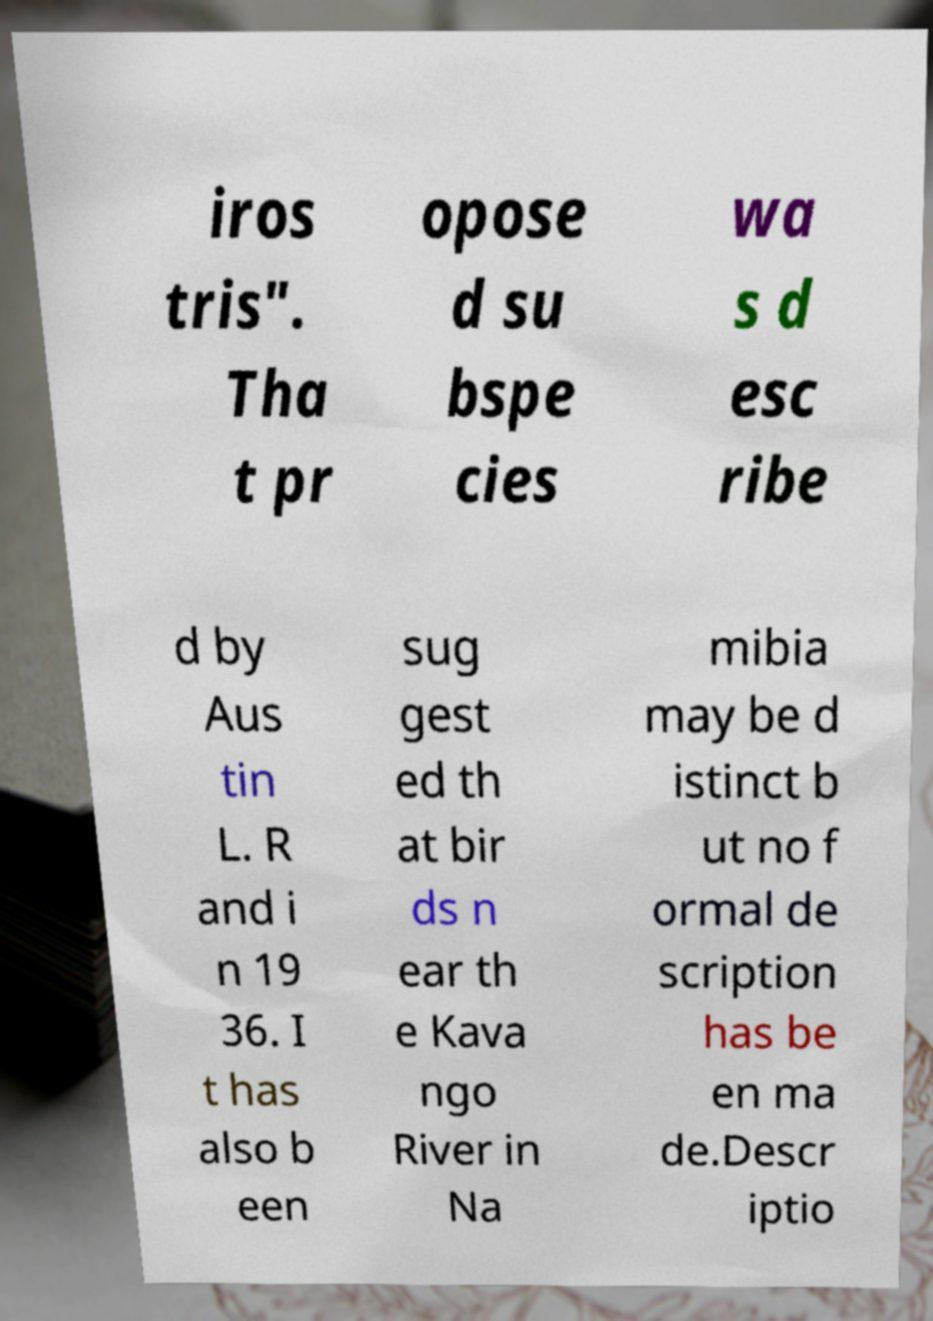I need the written content from this picture converted into text. Can you do that? iros tris". Tha t pr opose d su bspe cies wa s d esc ribe d by Aus tin L. R and i n 19 36. I t has also b een sug gest ed th at bir ds n ear th e Kava ngo River in Na mibia may be d istinct b ut no f ormal de scription has be en ma de.Descr iptio 